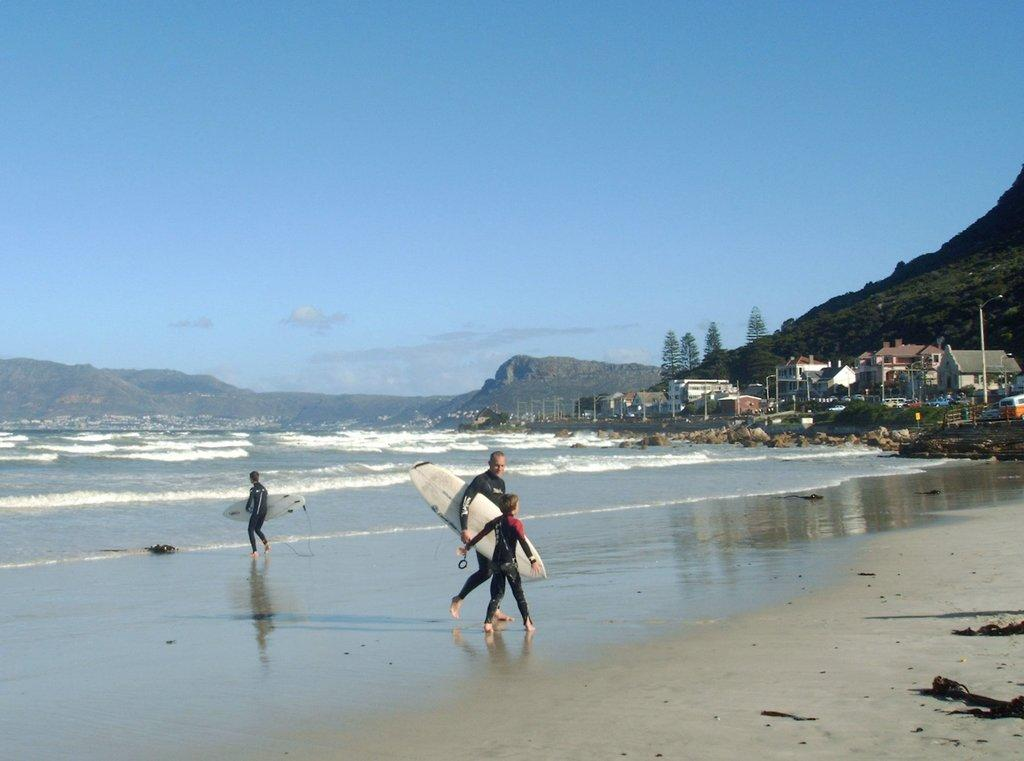What are the people in the foreground of the image doing? The people in the foreground of the image are carrying surfing boats. What can be seen in the background of the image? There are houses, trees, and mountains in the background of the image. What is the primary natural feature visible in the image? Water is visible in the image. What else is visible in the sky in the image? The sky is visible in the image. What type of stocking is the daughter wearing in the image? There is no daughter or stocking present in the image. What drug is being used by the people carrying surfing boats in the image? There is no drug use depicted in the image; the people are carrying surfing boats. 